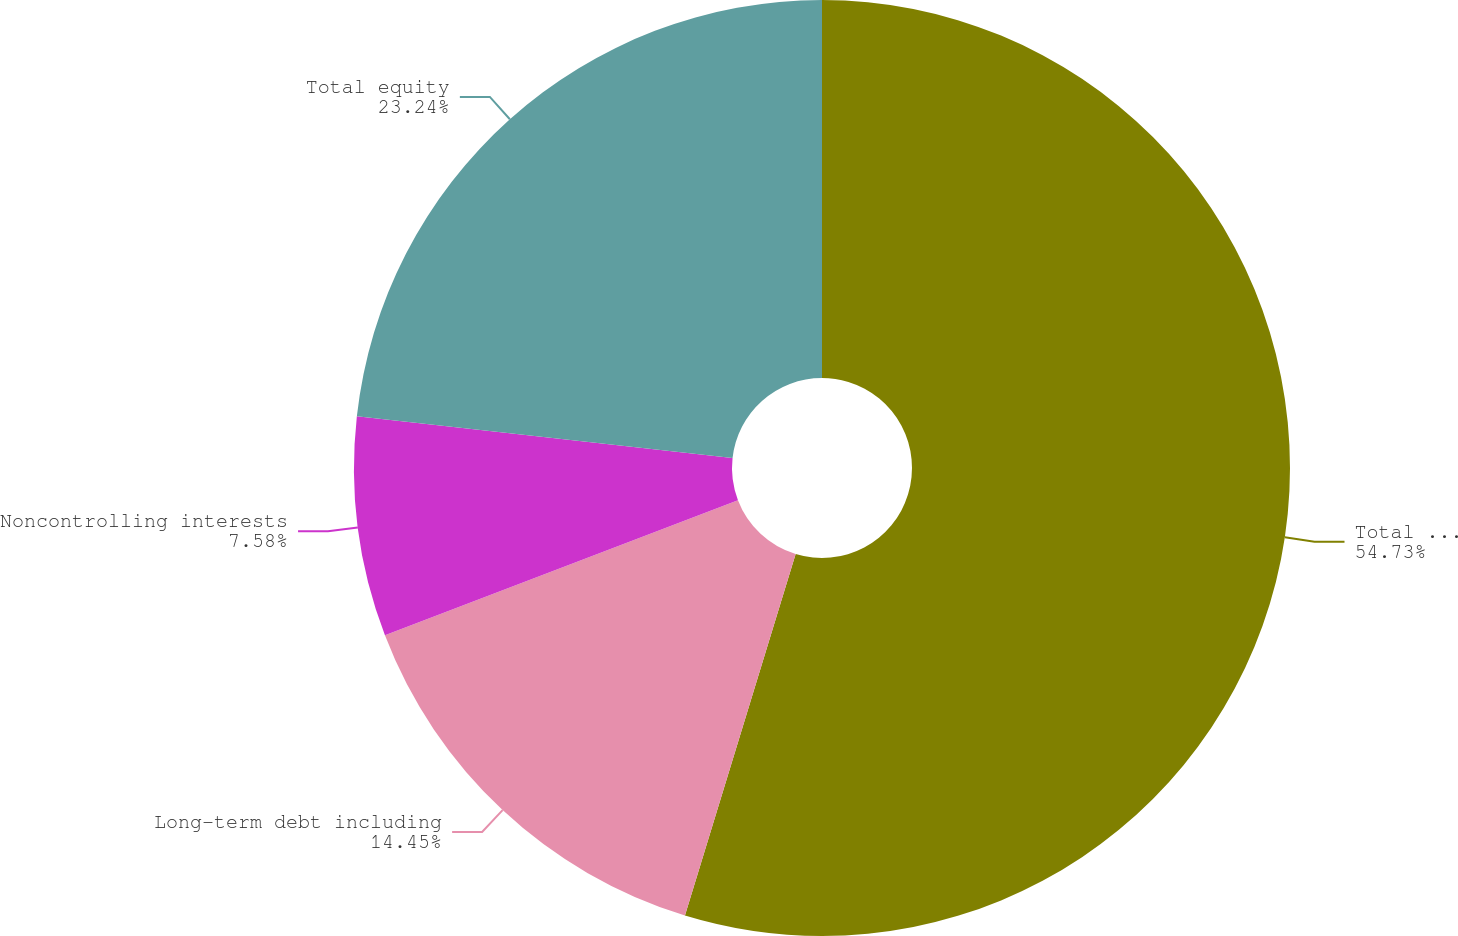<chart> <loc_0><loc_0><loc_500><loc_500><pie_chart><fcel>Total assets<fcel>Long-term debt including<fcel>Noncontrolling interests<fcel>Total equity<nl><fcel>54.73%<fcel>14.45%<fcel>7.58%<fcel>23.24%<nl></chart> 